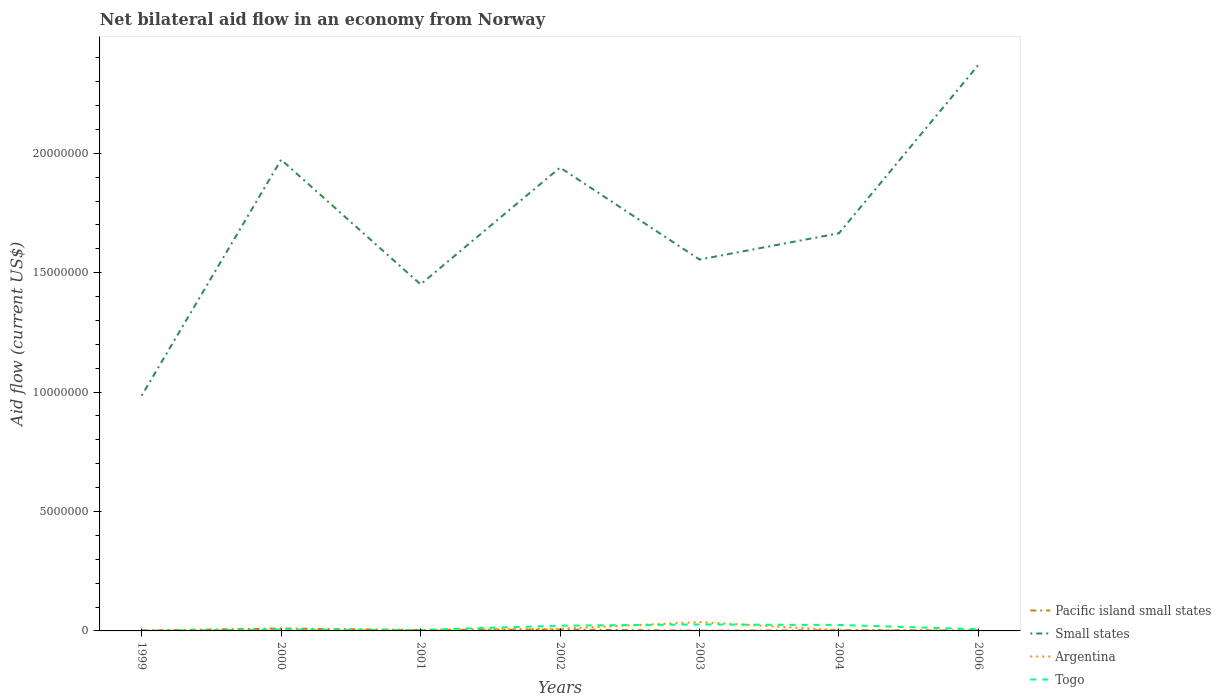How many different coloured lines are there?
Make the answer very short. 4. Across all years, what is the maximum net bilateral aid flow in Small states?
Ensure brevity in your answer.  9.85e+06. In which year was the net bilateral aid flow in Small states maximum?
Give a very brief answer. 1999. What is the total net bilateral aid flow in Small states in the graph?
Ensure brevity in your answer.  4.18e+06. Is the net bilateral aid flow in Pacific island small states strictly greater than the net bilateral aid flow in Small states over the years?
Provide a short and direct response. Yes. How many years are there in the graph?
Ensure brevity in your answer.  7. Are the values on the major ticks of Y-axis written in scientific E-notation?
Give a very brief answer. No. Does the graph contain any zero values?
Your answer should be compact. No. How many legend labels are there?
Provide a succinct answer. 4. What is the title of the graph?
Offer a terse response. Net bilateral aid flow in an economy from Norway. What is the label or title of the X-axis?
Offer a terse response. Years. What is the label or title of the Y-axis?
Provide a succinct answer. Aid flow (current US$). What is the Aid flow (current US$) of Small states in 1999?
Offer a very short reply. 9.85e+06. What is the Aid flow (current US$) in Argentina in 1999?
Your answer should be compact. 10000. What is the Aid flow (current US$) in Togo in 1999?
Offer a very short reply. 10000. What is the Aid flow (current US$) of Pacific island small states in 2000?
Keep it short and to the point. 1.00e+05. What is the Aid flow (current US$) in Small states in 2000?
Offer a terse response. 1.97e+07. What is the Aid flow (current US$) of Small states in 2001?
Provide a succinct answer. 1.45e+07. What is the Aid flow (current US$) of Togo in 2001?
Your answer should be compact. 4.00e+04. What is the Aid flow (current US$) in Pacific island small states in 2002?
Provide a succinct answer. 6.00e+04. What is the Aid flow (current US$) in Small states in 2002?
Offer a terse response. 1.94e+07. What is the Aid flow (current US$) in Small states in 2003?
Offer a very short reply. 1.56e+07. What is the Aid flow (current US$) of Argentina in 2003?
Provide a succinct answer. 3.70e+05. What is the Aid flow (current US$) in Small states in 2004?
Provide a succinct answer. 1.66e+07. What is the Aid flow (current US$) in Argentina in 2004?
Your answer should be compact. 3.00e+04. What is the Aid flow (current US$) in Pacific island small states in 2006?
Ensure brevity in your answer.  2.00e+04. What is the Aid flow (current US$) of Small states in 2006?
Your answer should be very brief. 2.37e+07. Across all years, what is the maximum Aid flow (current US$) in Small states?
Your answer should be compact. 2.37e+07. Across all years, what is the minimum Aid flow (current US$) in Small states?
Provide a short and direct response. 9.85e+06. What is the total Aid flow (current US$) of Small states in the graph?
Make the answer very short. 1.19e+08. What is the total Aid flow (current US$) in Argentina in the graph?
Make the answer very short. 5.70e+05. What is the total Aid flow (current US$) of Togo in the graph?
Your answer should be compact. 9.20e+05. What is the difference between the Aid flow (current US$) in Small states in 1999 and that in 2000?
Your response must be concise. -9.88e+06. What is the difference between the Aid flow (current US$) of Togo in 1999 and that in 2000?
Provide a short and direct response. -5.00e+04. What is the difference between the Aid flow (current US$) in Small states in 1999 and that in 2001?
Make the answer very short. -4.66e+06. What is the difference between the Aid flow (current US$) of Argentina in 1999 and that in 2001?
Give a very brief answer. -3.00e+04. What is the difference between the Aid flow (current US$) of Pacific island small states in 1999 and that in 2002?
Provide a succinct answer. -4.00e+04. What is the difference between the Aid flow (current US$) in Small states in 1999 and that in 2002?
Make the answer very short. -9.55e+06. What is the difference between the Aid flow (current US$) of Pacific island small states in 1999 and that in 2003?
Ensure brevity in your answer.  10000. What is the difference between the Aid flow (current US$) of Small states in 1999 and that in 2003?
Offer a terse response. -5.70e+06. What is the difference between the Aid flow (current US$) of Argentina in 1999 and that in 2003?
Give a very brief answer. -3.60e+05. What is the difference between the Aid flow (current US$) of Togo in 1999 and that in 2003?
Make the answer very short. -2.60e+05. What is the difference between the Aid flow (current US$) in Small states in 1999 and that in 2004?
Offer a terse response. -6.80e+06. What is the difference between the Aid flow (current US$) of Pacific island small states in 1999 and that in 2006?
Make the answer very short. 0. What is the difference between the Aid flow (current US$) of Small states in 1999 and that in 2006?
Provide a succinct answer. -1.38e+07. What is the difference between the Aid flow (current US$) of Togo in 1999 and that in 2006?
Keep it short and to the point. -6.00e+04. What is the difference between the Aid flow (current US$) in Small states in 2000 and that in 2001?
Provide a short and direct response. 5.22e+06. What is the difference between the Aid flow (current US$) in Pacific island small states in 2000 and that in 2002?
Keep it short and to the point. 4.00e+04. What is the difference between the Aid flow (current US$) of Small states in 2000 and that in 2002?
Your answer should be very brief. 3.30e+05. What is the difference between the Aid flow (current US$) of Argentina in 2000 and that in 2002?
Your answer should be very brief. -8.00e+04. What is the difference between the Aid flow (current US$) in Togo in 2000 and that in 2002?
Keep it short and to the point. -1.60e+05. What is the difference between the Aid flow (current US$) in Small states in 2000 and that in 2003?
Offer a very short reply. 4.18e+06. What is the difference between the Aid flow (current US$) of Argentina in 2000 and that in 2003?
Provide a succinct answer. -3.60e+05. What is the difference between the Aid flow (current US$) of Togo in 2000 and that in 2003?
Your answer should be compact. -2.10e+05. What is the difference between the Aid flow (current US$) in Small states in 2000 and that in 2004?
Provide a succinct answer. 3.08e+06. What is the difference between the Aid flow (current US$) in Small states in 2000 and that in 2006?
Ensure brevity in your answer.  -3.97e+06. What is the difference between the Aid flow (current US$) in Argentina in 2000 and that in 2006?
Keep it short and to the point. -10000. What is the difference between the Aid flow (current US$) of Togo in 2000 and that in 2006?
Ensure brevity in your answer.  -10000. What is the difference between the Aid flow (current US$) of Pacific island small states in 2001 and that in 2002?
Provide a succinct answer. -2.00e+04. What is the difference between the Aid flow (current US$) of Small states in 2001 and that in 2002?
Offer a very short reply. -4.89e+06. What is the difference between the Aid flow (current US$) of Argentina in 2001 and that in 2002?
Your answer should be very brief. -5.00e+04. What is the difference between the Aid flow (current US$) of Pacific island small states in 2001 and that in 2003?
Offer a very short reply. 3.00e+04. What is the difference between the Aid flow (current US$) of Small states in 2001 and that in 2003?
Your answer should be compact. -1.04e+06. What is the difference between the Aid flow (current US$) of Argentina in 2001 and that in 2003?
Ensure brevity in your answer.  -3.30e+05. What is the difference between the Aid flow (current US$) of Togo in 2001 and that in 2003?
Your answer should be very brief. -2.30e+05. What is the difference between the Aid flow (current US$) of Pacific island small states in 2001 and that in 2004?
Make the answer very short. 10000. What is the difference between the Aid flow (current US$) in Small states in 2001 and that in 2004?
Your answer should be compact. -2.14e+06. What is the difference between the Aid flow (current US$) in Argentina in 2001 and that in 2004?
Your answer should be very brief. 10000. What is the difference between the Aid flow (current US$) in Togo in 2001 and that in 2004?
Make the answer very short. -2.10e+05. What is the difference between the Aid flow (current US$) in Small states in 2001 and that in 2006?
Your answer should be compact. -9.19e+06. What is the difference between the Aid flow (current US$) of Small states in 2002 and that in 2003?
Provide a short and direct response. 3.85e+06. What is the difference between the Aid flow (current US$) of Argentina in 2002 and that in 2003?
Your answer should be very brief. -2.80e+05. What is the difference between the Aid flow (current US$) of Small states in 2002 and that in 2004?
Ensure brevity in your answer.  2.75e+06. What is the difference between the Aid flow (current US$) in Pacific island small states in 2002 and that in 2006?
Provide a short and direct response. 4.00e+04. What is the difference between the Aid flow (current US$) of Small states in 2002 and that in 2006?
Give a very brief answer. -4.30e+06. What is the difference between the Aid flow (current US$) of Pacific island small states in 2003 and that in 2004?
Ensure brevity in your answer.  -2.00e+04. What is the difference between the Aid flow (current US$) of Small states in 2003 and that in 2004?
Ensure brevity in your answer.  -1.10e+06. What is the difference between the Aid flow (current US$) of Argentina in 2003 and that in 2004?
Provide a succinct answer. 3.40e+05. What is the difference between the Aid flow (current US$) of Pacific island small states in 2003 and that in 2006?
Your answer should be compact. -10000. What is the difference between the Aid flow (current US$) in Small states in 2003 and that in 2006?
Ensure brevity in your answer.  -8.15e+06. What is the difference between the Aid flow (current US$) of Argentina in 2003 and that in 2006?
Offer a very short reply. 3.50e+05. What is the difference between the Aid flow (current US$) of Togo in 2003 and that in 2006?
Your answer should be very brief. 2.00e+05. What is the difference between the Aid flow (current US$) of Pacific island small states in 2004 and that in 2006?
Your response must be concise. 10000. What is the difference between the Aid flow (current US$) in Small states in 2004 and that in 2006?
Your answer should be very brief. -7.05e+06. What is the difference between the Aid flow (current US$) of Pacific island small states in 1999 and the Aid flow (current US$) of Small states in 2000?
Your response must be concise. -1.97e+07. What is the difference between the Aid flow (current US$) in Pacific island small states in 1999 and the Aid flow (current US$) in Argentina in 2000?
Keep it short and to the point. 10000. What is the difference between the Aid flow (current US$) of Small states in 1999 and the Aid flow (current US$) of Argentina in 2000?
Make the answer very short. 9.84e+06. What is the difference between the Aid flow (current US$) in Small states in 1999 and the Aid flow (current US$) in Togo in 2000?
Keep it short and to the point. 9.79e+06. What is the difference between the Aid flow (current US$) in Argentina in 1999 and the Aid flow (current US$) in Togo in 2000?
Provide a succinct answer. -5.00e+04. What is the difference between the Aid flow (current US$) in Pacific island small states in 1999 and the Aid flow (current US$) in Small states in 2001?
Offer a very short reply. -1.45e+07. What is the difference between the Aid flow (current US$) of Pacific island small states in 1999 and the Aid flow (current US$) of Argentina in 2001?
Provide a short and direct response. -2.00e+04. What is the difference between the Aid flow (current US$) of Small states in 1999 and the Aid flow (current US$) of Argentina in 2001?
Give a very brief answer. 9.81e+06. What is the difference between the Aid flow (current US$) of Small states in 1999 and the Aid flow (current US$) of Togo in 2001?
Give a very brief answer. 9.81e+06. What is the difference between the Aid flow (current US$) of Argentina in 1999 and the Aid flow (current US$) of Togo in 2001?
Offer a terse response. -3.00e+04. What is the difference between the Aid flow (current US$) in Pacific island small states in 1999 and the Aid flow (current US$) in Small states in 2002?
Offer a very short reply. -1.94e+07. What is the difference between the Aid flow (current US$) of Pacific island small states in 1999 and the Aid flow (current US$) of Togo in 2002?
Provide a short and direct response. -2.00e+05. What is the difference between the Aid flow (current US$) of Small states in 1999 and the Aid flow (current US$) of Argentina in 2002?
Your response must be concise. 9.76e+06. What is the difference between the Aid flow (current US$) of Small states in 1999 and the Aid flow (current US$) of Togo in 2002?
Offer a very short reply. 9.63e+06. What is the difference between the Aid flow (current US$) of Pacific island small states in 1999 and the Aid flow (current US$) of Small states in 2003?
Provide a succinct answer. -1.55e+07. What is the difference between the Aid flow (current US$) of Pacific island small states in 1999 and the Aid flow (current US$) of Argentina in 2003?
Keep it short and to the point. -3.50e+05. What is the difference between the Aid flow (current US$) of Small states in 1999 and the Aid flow (current US$) of Argentina in 2003?
Your response must be concise. 9.48e+06. What is the difference between the Aid flow (current US$) of Small states in 1999 and the Aid flow (current US$) of Togo in 2003?
Keep it short and to the point. 9.58e+06. What is the difference between the Aid flow (current US$) in Pacific island small states in 1999 and the Aid flow (current US$) in Small states in 2004?
Offer a terse response. -1.66e+07. What is the difference between the Aid flow (current US$) of Small states in 1999 and the Aid flow (current US$) of Argentina in 2004?
Keep it short and to the point. 9.82e+06. What is the difference between the Aid flow (current US$) of Small states in 1999 and the Aid flow (current US$) of Togo in 2004?
Your answer should be very brief. 9.60e+06. What is the difference between the Aid flow (current US$) in Argentina in 1999 and the Aid flow (current US$) in Togo in 2004?
Provide a short and direct response. -2.40e+05. What is the difference between the Aid flow (current US$) of Pacific island small states in 1999 and the Aid flow (current US$) of Small states in 2006?
Offer a very short reply. -2.37e+07. What is the difference between the Aid flow (current US$) in Pacific island small states in 1999 and the Aid flow (current US$) in Argentina in 2006?
Your answer should be compact. 0. What is the difference between the Aid flow (current US$) in Pacific island small states in 1999 and the Aid flow (current US$) in Togo in 2006?
Keep it short and to the point. -5.00e+04. What is the difference between the Aid flow (current US$) of Small states in 1999 and the Aid flow (current US$) of Argentina in 2006?
Offer a very short reply. 9.83e+06. What is the difference between the Aid flow (current US$) in Small states in 1999 and the Aid flow (current US$) in Togo in 2006?
Provide a succinct answer. 9.78e+06. What is the difference between the Aid flow (current US$) of Pacific island small states in 2000 and the Aid flow (current US$) of Small states in 2001?
Give a very brief answer. -1.44e+07. What is the difference between the Aid flow (current US$) in Pacific island small states in 2000 and the Aid flow (current US$) in Argentina in 2001?
Provide a short and direct response. 6.00e+04. What is the difference between the Aid flow (current US$) in Small states in 2000 and the Aid flow (current US$) in Argentina in 2001?
Give a very brief answer. 1.97e+07. What is the difference between the Aid flow (current US$) of Small states in 2000 and the Aid flow (current US$) of Togo in 2001?
Your answer should be compact. 1.97e+07. What is the difference between the Aid flow (current US$) of Argentina in 2000 and the Aid flow (current US$) of Togo in 2001?
Make the answer very short. -3.00e+04. What is the difference between the Aid flow (current US$) of Pacific island small states in 2000 and the Aid flow (current US$) of Small states in 2002?
Keep it short and to the point. -1.93e+07. What is the difference between the Aid flow (current US$) in Pacific island small states in 2000 and the Aid flow (current US$) in Argentina in 2002?
Offer a terse response. 10000. What is the difference between the Aid flow (current US$) in Small states in 2000 and the Aid flow (current US$) in Argentina in 2002?
Your response must be concise. 1.96e+07. What is the difference between the Aid flow (current US$) of Small states in 2000 and the Aid flow (current US$) of Togo in 2002?
Your answer should be very brief. 1.95e+07. What is the difference between the Aid flow (current US$) in Pacific island small states in 2000 and the Aid flow (current US$) in Small states in 2003?
Give a very brief answer. -1.54e+07. What is the difference between the Aid flow (current US$) of Pacific island small states in 2000 and the Aid flow (current US$) of Argentina in 2003?
Your answer should be very brief. -2.70e+05. What is the difference between the Aid flow (current US$) of Pacific island small states in 2000 and the Aid flow (current US$) of Togo in 2003?
Make the answer very short. -1.70e+05. What is the difference between the Aid flow (current US$) of Small states in 2000 and the Aid flow (current US$) of Argentina in 2003?
Your answer should be compact. 1.94e+07. What is the difference between the Aid flow (current US$) in Small states in 2000 and the Aid flow (current US$) in Togo in 2003?
Offer a terse response. 1.95e+07. What is the difference between the Aid flow (current US$) of Pacific island small states in 2000 and the Aid flow (current US$) of Small states in 2004?
Your answer should be compact. -1.66e+07. What is the difference between the Aid flow (current US$) of Pacific island small states in 2000 and the Aid flow (current US$) of Argentina in 2004?
Your answer should be very brief. 7.00e+04. What is the difference between the Aid flow (current US$) in Small states in 2000 and the Aid flow (current US$) in Argentina in 2004?
Your response must be concise. 1.97e+07. What is the difference between the Aid flow (current US$) of Small states in 2000 and the Aid flow (current US$) of Togo in 2004?
Your answer should be compact. 1.95e+07. What is the difference between the Aid flow (current US$) of Pacific island small states in 2000 and the Aid flow (current US$) of Small states in 2006?
Give a very brief answer. -2.36e+07. What is the difference between the Aid flow (current US$) in Small states in 2000 and the Aid flow (current US$) in Argentina in 2006?
Your answer should be compact. 1.97e+07. What is the difference between the Aid flow (current US$) in Small states in 2000 and the Aid flow (current US$) in Togo in 2006?
Provide a short and direct response. 1.97e+07. What is the difference between the Aid flow (current US$) in Argentina in 2000 and the Aid flow (current US$) in Togo in 2006?
Your answer should be compact. -6.00e+04. What is the difference between the Aid flow (current US$) in Pacific island small states in 2001 and the Aid flow (current US$) in Small states in 2002?
Ensure brevity in your answer.  -1.94e+07. What is the difference between the Aid flow (current US$) in Small states in 2001 and the Aid flow (current US$) in Argentina in 2002?
Make the answer very short. 1.44e+07. What is the difference between the Aid flow (current US$) in Small states in 2001 and the Aid flow (current US$) in Togo in 2002?
Offer a very short reply. 1.43e+07. What is the difference between the Aid flow (current US$) in Argentina in 2001 and the Aid flow (current US$) in Togo in 2002?
Provide a succinct answer. -1.80e+05. What is the difference between the Aid flow (current US$) of Pacific island small states in 2001 and the Aid flow (current US$) of Small states in 2003?
Your answer should be very brief. -1.55e+07. What is the difference between the Aid flow (current US$) of Pacific island small states in 2001 and the Aid flow (current US$) of Argentina in 2003?
Give a very brief answer. -3.30e+05. What is the difference between the Aid flow (current US$) in Pacific island small states in 2001 and the Aid flow (current US$) in Togo in 2003?
Your response must be concise. -2.30e+05. What is the difference between the Aid flow (current US$) of Small states in 2001 and the Aid flow (current US$) of Argentina in 2003?
Give a very brief answer. 1.41e+07. What is the difference between the Aid flow (current US$) of Small states in 2001 and the Aid flow (current US$) of Togo in 2003?
Ensure brevity in your answer.  1.42e+07. What is the difference between the Aid flow (current US$) of Pacific island small states in 2001 and the Aid flow (current US$) of Small states in 2004?
Ensure brevity in your answer.  -1.66e+07. What is the difference between the Aid flow (current US$) in Small states in 2001 and the Aid flow (current US$) in Argentina in 2004?
Offer a very short reply. 1.45e+07. What is the difference between the Aid flow (current US$) of Small states in 2001 and the Aid flow (current US$) of Togo in 2004?
Make the answer very short. 1.43e+07. What is the difference between the Aid flow (current US$) in Argentina in 2001 and the Aid flow (current US$) in Togo in 2004?
Ensure brevity in your answer.  -2.10e+05. What is the difference between the Aid flow (current US$) of Pacific island small states in 2001 and the Aid flow (current US$) of Small states in 2006?
Make the answer very short. -2.37e+07. What is the difference between the Aid flow (current US$) of Pacific island small states in 2001 and the Aid flow (current US$) of Argentina in 2006?
Your answer should be very brief. 2.00e+04. What is the difference between the Aid flow (current US$) in Small states in 2001 and the Aid flow (current US$) in Argentina in 2006?
Ensure brevity in your answer.  1.45e+07. What is the difference between the Aid flow (current US$) in Small states in 2001 and the Aid flow (current US$) in Togo in 2006?
Keep it short and to the point. 1.44e+07. What is the difference between the Aid flow (current US$) in Argentina in 2001 and the Aid flow (current US$) in Togo in 2006?
Provide a succinct answer. -3.00e+04. What is the difference between the Aid flow (current US$) in Pacific island small states in 2002 and the Aid flow (current US$) in Small states in 2003?
Make the answer very short. -1.55e+07. What is the difference between the Aid flow (current US$) in Pacific island small states in 2002 and the Aid flow (current US$) in Argentina in 2003?
Ensure brevity in your answer.  -3.10e+05. What is the difference between the Aid flow (current US$) of Small states in 2002 and the Aid flow (current US$) of Argentina in 2003?
Provide a succinct answer. 1.90e+07. What is the difference between the Aid flow (current US$) in Small states in 2002 and the Aid flow (current US$) in Togo in 2003?
Offer a terse response. 1.91e+07. What is the difference between the Aid flow (current US$) of Argentina in 2002 and the Aid flow (current US$) of Togo in 2003?
Your response must be concise. -1.80e+05. What is the difference between the Aid flow (current US$) of Pacific island small states in 2002 and the Aid flow (current US$) of Small states in 2004?
Offer a terse response. -1.66e+07. What is the difference between the Aid flow (current US$) in Small states in 2002 and the Aid flow (current US$) in Argentina in 2004?
Provide a succinct answer. 1.94e+07. What is the difference between the Aid flow (current US$) in Small states in 2002 and the Aid flow (current US$) in Togo in 2004?
Offer a very short reply. 1.92e+07. What is the difference between the Aid flow (current US$) of Pacific island small states in 2002 and the Aid flow (current US$) of Small states in 2006?
Give a very brief answer. -2.36e+07. What is the difference between the Aid flow (current US$) in Pacific island small states in 2002 and the Aid flow (current US$) in Argentina in 2006?
Ensure brevity in your answer.  4.00e+04. What is the difference between the Aid flow (current US$) in Small states in 2002 and the Aid flow (current US$) in Argentina in 2006?
Your answer should be compact. 1.94e+07. What is the difference between the Aid flow (current US$) in Small states in 2002 and the Aid flow (current US$) in Togo in 2006?
Keep it short and to the point. 1.93e+07. What is the difference between the Aid flow (current US$) in Argentina in 2002 and the Aid flow (current US$) in Togo in 2006?
Provide a short and direct response. 2.00e+04. What is the difference between the Aid flow (current US$) of Pacific island small states in 2003 and the Aid flow (current US$) of Small states in 2004?
Give a very brief answer. -1.66e+07. What is the difference between the Aid flow (current US$) in Pacific island small states in 2003 and the Aid flow (current US$) in Togo in 2004?
Provide a succinct answer. -2.40e+05. What is the difference between the Aid flow (current US$) in Small states in 2003 and the Aid flow (current US$) in Argentina in 2004?
Your response must be concise. 1.55e+07. What is the difference between the Aid flow (current US$) in Small states in 2003 and the Aid flow (current US$) in Togo in 2004?
Ensure brevity in your answer.  1.53e+07. What is the difference between the Aid flow (current US$) in Argentina in 2003 and the Aid flow (current US$) in Togo in 2004?
Ensure brevity in your answer.  1.20e+05. What is the difference between the Aid flow (current US$) in Pacific island small states in 2003 and the Aid flow (current US$) in Small states in 2006?
Give a very brief answer. -2.37e+07. What is the difference between the Aid flow (current US$) of Pacific island small states in 2003 and the Aid flow (current US$) of Argentina in 2006?
Provide a succinct answer. -10000. What is the difference between the Aid flow (current US$) in Small states in 2003 and the Aid flow (current US$) in Argentina in 2006?
Offer a very short reply. 1.55e+07. What is the difference between the Aid flow (current US$) in Small states in 2003 and the Aid flow (current US$) in Togo in 2006?
Provide a succinct answer. 1.55e+07. What is the difference between the Aid flow (current US$) of Argentina in 2003 and the Aid flow (current US$) of Togo in 2006?
Offer a terse response. 3.00e+05. What is the difference between the Aid flow (current US$) of Pacific island small states in 2004 and the Aid flow (current US$) of Small states in 2006?
Provide a short and direct response. -2.37e+07. What is the difference between the Aid flow (current US$) of Small states in 2004 and the Aid flow (current US$) of Argentina in 2006?
Provide a short and direct response. 1.66e+07. What is the difference between the Aid flow (current US$) in Small states in 2004 and the Aid flow (current US$) in Togo in 2006?
Your answer should be very brief. 1.66e+07. What is the average Aid flow (current US$) of Pacific island small states per year?
Offer a terse response. 4.00e+04. What is the average Aid flow (current US$) in Small states per year?
Offer a terse response. 1.71e+07. What is the average Aid flow (current US$) in Argentina per year?
Make the answer very short. 8.14e+04. What is the average Aid flow (current US$) of Togo per year?
Keep it short and to the point. 1.31e+05. In the year 1999, what is the difference between the Aid flow (current US$) in Pacific island small states and Aid flow (current US$) in Small states?
Make the answer very short. -9.83e+06. In the year 1999, what is the difference between the Aid flow (current US$) of Pacific island small states and Aid flow (current US$) of Togo?
Give a very brief answer. 10000. In the year 1999, what is the difference between the Aid flow (current US$) of Small states and Aid flow (current US$) of Argentina?
Your answer should be very brief. 9.84e+06. In the year 1999, what is the difference between the Aid flow (current US$) of Small states and Aid flow (current US$) of Togo?
Your response must be concise. 9.84e+06. In the year 1999, what is the difference between the Aid flow (current US$) in Argentina and Aid flow (current US$) in Togo?
Keep it short and to the point. 0. In the year 2000, what is the difference between the Aid flow (current US$) of Pacific island small states and Aid flow (current US$) of Small states?
Ensure brevity in your answer.  -1.96e+07. In the year 2000, what is the difference between the Aid flow (current US$) in Pacific island small states and Aid flow (current US$) in Argentina?
Offer a very short reply. 9.00e+04. In the year 2000, what is the difference between the Aid flow (current US$) in Pacific island small states and Aid flow (current US$) in Togo?
Your response must be concise. 4.00e+04. In the year 2000, what is the difference between the Aid flow (current US$) in Small states and Aid flow (current US$) in Argentina?
Offer a very short reply. 1.97e+07. In the year 2000, what is the difference between the Aid flow (current US$) of Small states and Aid flow (current US$) of Togo?
Your answer should be very brief. 1.97e+07. In the year 2000, what is the difference between the Aid flow (current US$) of Argentina and Aid flow (current US$) of Togo?
Offer a very short reply. -5.00e+04. In the year 2001, what is the difference between the Aid flow (current US$) in Pacific island small states and Aid flow (current US$) in Small states?
Provide a succinct answer. -1.45e+07. In the year 2001, what is the difference between the Aid flow (current US$) in Pacific island small states and Aid flow (current US$) in Argentina?
Your response must be concise. 0. In the year 2001, what is the difference between the Aid flow (current US$) of Small states and Aid flow (current US$) of Argentina?
Ensure brevity in your answer.  1.45e+07. In the year 2001, what is the difference between the Aid flow (current US$) in Small states and Aid flow (current US$) in Togo?
Your answer should be very brief. 1.45e+07. In the year 2001, what is the difference between the Aid flow (current US$) in Argentina and Aid flow (current US$) in Togo?
Give a very brief answer. 0. In the year 2002, what is the difference between the Aid flow (current US$) of Pacific island small states and Aid flow (current US$) of Small states?
Give a very brief answer. -1.93e+07. In the year 2002, what is the difference between the Aid flow (current US$) of Small states and Aid flow (current US$) of Argentina?
Keep it short and to the point. 1.93e+07. In the year 2002, what is the difference between the Aid flow (current US$) of Small states and Aid flow (current US$) of Togo?
Provide a short and direct response. 1.92e+07. In the year 2003, what is the difference between the Aid flow (current US$) in Pacific island small states and Aid flow (current US$) in Small states?
Your answer should be compact. -1.55e+07. In the year 2003, what is the difference between the Aid flow (current US$) of Pacific island small states and Aid flow (current US$) of Argentina?
Offer a terse response. -3.60e+05. In the year 2003, what is the difference between the Aid flow (current US$) of Small states and Aid flow (current US$) of Argentina?
Ensure brevity in your answer.  1.52e+07. In the year 2003, what is the difference between the Aid flow (current US$) in Small states and Aid flow (current US$) in Togo?
Give a very brief answer. 1.53e+07. In the year 2004, what is the difference between the Aid flow (current US$) of Pacific island small states and Aid flow (current US$) of Small states?
Your answer should be compact. -1.66e+07. In the year 2004, what is the difference between the Aid flow (current US$) of Pacific island small states and Aid flow (current US$) of Togo?
Provide a succinct answer. -2.20e+05. In the year 2004, what is the difference between the Aid flow (current US$) in Small states and Aid flow (current US$) in Argentina?
Offer a very short reply. 1.66e+07. In the year 2004, what is the difference between the Aid flow (current US$) of Small states and Aid flow (current US$) of Togo?
Give a very brief answer. 1.64e+07. In the year 2006, what is the difference between the Aid flow (current US$) of Pacific island small states and Aid flow (current US$) of Small states?
Provide a short and direct response. -2.37e+07. In the year 2006, what is the difference between the Aid flow (current US$) of Pacific island small states and Aid flow (current US$) of Togo?
Provide a short and direct response. -5.00e+04. In the year 2006, what is the difference between the Aid flow (current US$) of Small states and Aid flow (current US$) of Argentina?
Your answer should be compact. 2.37e+07. In the year 2006, what is the difference between the Aid flow (current US$) in Small states and Aid flow (current US$) in Togo?
Give a very brief answer. 2.36e+07. In the year 2006, what is the difference between the Aid flow (current US$) in Argentina and Aid flow (current US$) in Togo?
Keep it short and to the point. -5.00e+04. What is the ratio of the Aid flow (current US$) in Pacific island small states in 1999 to that in 2000?
Your answer should be compact. 0.2. What is the ratio of the Aid flow (current US$) in Small states in 1999 to that in 2000?
Provide a succinct answer. 0.5. What is the ratio of the Aid flow (current US$) in Pacific island small states in 1999 to that in 2001?
Make the answer very short. 0.5. What is the ratio of the Aid flow (current US$) of Small states in 1999 to that in 2001?
Give a very brief answer. 0.68. What is the ratio of the Aid flow (current US$) of Argentina in 1999 to that in 2001?
Your answer should be compact. 0.25. What is the ratio of the Aid flow (current US$) in Togo in 1999 to that in 2001?
Your answer should be very brief. 0.25. What is the ratio of the Aid flow (current US$) of Pacific island small states in 1999 to that in 2002?
Your answer should be very brief. 0.33. What is the ratio of the Aid flow (current US$) of Small states in 1999 to that in 2002?
Give a very brief answer. 0.51. What is the ratio of the Aid flow (current US$) in Togo in 1999 to that in 2002?
Give a very brief answer. 0.05. What is the ratio of the Aid flow (current US$) in Pacific island small states in 1999 to that in 2003?
Ensure brevity in your answer.  2. What is the ratio of the Aid flow (current US$) of Small states in 1999 to that in 2003?
Ensure brevity in your answer.  0.63. What is the ratio of the Aid flow (current US$) of Argentina in 1999 to that in 2003?
Keep it short and to the point. 0.03. What is the ratio of the Aid flow (current US$) in Togo in 1999 to that in 2003?
Give a very brief answer. 0.04. What is the ratio of the Aid flow (current US$) in Pacific island small states in 1999 to that in 2004?
Offer a very short reply. 0.67. What is the ratio of the Aid flow (current US$) in Small states in 1999 to that in 2004?
Offer a very short reply. 0.59. What is the ratio of the Aid flow (current US$) of Togo in 1999 to that in 2004?
Your response must be concise. 0.04. What is the ratio of the Aid flow (current US$) in Small states in 1999 to that in 2006?
Your response must be concise. 0.42. What is the ratio of the Aid flow (current US$) of Argentina in 1999 to that in 2006?
Ensure brevity in your answer.  0.5. What is the ratio of the Aid flow (current US$) of Togo in 1999 to that in 2006?
Your response must be concise. 0.14. What is the ratio of the Aid flow (current US$) in Small states in 2000 to that in 2001?
Ensure brevity in your answer.  1.36. What is the ratio of the Aid flow (current US$) in Argentina in 2000 to that in 2001?
Your answer should be very brief. 0.25. What is the ratio of the Aid flow (current US$) in Pacific island small states in 2000 to that in 2002?
Your answer should be compact. 1.67. What is the ratio of the Aid flow (current US$) of Togo in 2000 to that in 2002?
Your response must be concise. 0.27. What is the ratio of the Aid flow (current US$) in Pacific island small states in 2000 to that in 2003?
Your answer should be compact. 10. What is the ratio of the Aid flow (current US$) of Small states in 2000 to that in 2003?
Give a very brief answer. 1.27. What is the ratio of the Aid flow (current US$) of Argentina in 2000 to that in 2003?
Ensure brevity in your answer.  0.03. What is the ratio of the Aid flow (current US$) of Togo in 2000 to that in 2003?
Ensure brevity in your answer.  0.22. What is the ratio of the Aid flow (current US$) in Pacific island small states in 2000 to that in 2004?
Offer a very short reply. 3.33. What is the ratio of the Aid flow (current US$) in Small states in 2000 to that in 2004?
Your response must be concise. 1.19. What is the ratio of the Aid flow (current US$) of Togo in 2000 to that in 2004?
Keep it short and to the point. 0.24. What is the ratio of the Aid flow (current US$) in Pacific island small states in 2000 to that in 2006?
Ensure brevity in your answer.  5. What is the ratio of the Aid flow (current US$) in Small states in 2000 to that in 2006?
Give a very brief answer. 0.83. What is the ratio of the Aid flow (current US$) of Argentina in 2000 to that in 2006?
Offer a very short reply. 0.5. What is the ratio of the Aid flow (current US$) of Togo in 2000 to that in 2006?
Give a very brief answer. 0.86. What is the ratio of the Aid flow (current US$) in Small states in 2001 to that in 2002?
Offer a terse response. 0.75. What is the ratio of the Aid flow (current US$) of Argentina in 2001 to that in 2002?
Offer a terse response. 0.44. What is the ratio of the Aid flow (current US$) in Togo in 2001 to that in 2002?
Offer a terse response. 0.18. What is the ratio of the Aid flow (current US$) of Pacific island small states in 2001 to that in 2003?
Offer a very short reply. 4. What is the ratio of the Aid flow (current US$) of Small states in 2001 to that in 2003?
Offer a terse response. 0.93. What is the ratio of the Aid flow (current US$) in Argentina in 2001 to that in 2003?
Provide a short and direct response. 0.11. What is the ratio of the Aid flow (current US$) of Togo in 2001 to that in 2003?
Your response must be concise. 0.15. What is the ratio of the Aid flow (current US$) of Pacific island small states in 2001 to that in 2004?
Offer a terse response. 1.33. What is the ratio of the Aid flow (current US$) in Small states in 2001 to that in 2004?
Give a very brief answer. 0.87. What is the ratio of the Aid flow (current US$) in Togo in 2001 to that in 2004?
Make the answer very short. 0.16. What is the ratio of the Aid flow (current US$) in Small states in 2001 to that in 2006?
Offer a very short reply. 0.61. What is the ratio of the Aid flow (current US$) of Argentina in 2001 to that in 2006?
Give a very brief answer. 2. What is the ratio of the Aid flow (current US$) of Togo in 2001 to that in 2006?
Provide a short and direct response. 0.57. What is the ratio of the Aid flow (current US$) of Pacific island small states in 2002 to that in 2003?
Offer a terse response. 6. What is the ratio of the Aid flow (current US$) of Small states in 2002 to that in 2003?
Keep it short and to the point. 1.25. What is the ratio of the Aid flow (current US$) of Argentina in 2002 to that in 2003?
Offer a terse response. 0.24. What is the ratio of the Aid flow (current US$) of Togo in 2002 to that in 2003?
Provide a short and direct response. 0.81. What is the ratio of the Aid flow (current US$) of Pacific island small states in 2002 to that in 2004?
Your answer should be compact. 2. What is the ratio of the Aid flow (current US$) of Small states in 2002 to that in 2004?
Your answer should be very brief. 1.17. What is the ratio of the Aid flow (current US$) in Togo in 2002 to that in 2004?
Your answer should be compact. 0.88. What is the ratio of the Aid flow (current US$) of Pacific island small states in 2002 to that in 2006?
Your answer should be compact. 3. What is the ratio of the Aid flow (current US$) in Small states in 2002 to that in 2006?
Provide a succinct answer. 0.82. What is the ratio of the Aid flow (current US$) in Togo in 2002 to that in 2006?
Your answer should be very brief. 3.14. What is the ratio of the Aid flow (current US$) of Pacific island small states in 2003 to that in 2004?
Make the answer very short. 0.33. What is the ratio of the Aid flow (current US$) of Small states in 2003 to that in 2004?
Your answer should be compact. 0.93. What is the ratio of the Aid flow (current US$) of Argentina in 2003 to that in 2004?
Your answer should be compact. 12.33. What is the ratio of the Aid flow (current US$) of Pacific island small states in 2003 to that in 2006?
Make the answer very short. 0.5. What is the ratio of the Aid flow (current US$) in Small states in 2003 to that in 2006?
Ensure brevity in your answer.  0.66. What is the ratio of the Aid flow (current US$) of Togo in 2003 to that in 2006?
Your response must be concise. 3.86. What is the ratio of the Aid flow (current US$) in Small states in 2004 to that in 2006?
Offer a terse response. 0.7. What is the ratio of the Aid flow (current US$) in Togo in 2004 to that in 2006?
Your answer should be very brief. 3.57. What is the difference between the highest and the second highest Aid flow (current US$) in Pacific island small states?
Your response must be concise. 4.00e+04. What is the difference between the highest and the second highest Aid flow (current US$) of Small states?
Give a very brief answer. 3.97e+06. What is the difference between the highest and the second highest Aid flow (current US$) of Argentina?
Provide a succinct answer. 2.80e+05. What is the difference between the highest and the second highest Aid flow (current US$) in Togo?
Make the answer very short. 2.00e+04. What is the difference between the highest and the lowest Aid flow (current US$) of Small states?
Give a very brief answer. 1.38e+07. What is the difference between the highest and the lowest Aid flow (current US$) of Argentina?
Keep it short and to the point. 3.60e+05. What is the difference between the highest and the lowest Aid flow (current US$) in Togo?
Give a very brief answer. 2.60e+05. 